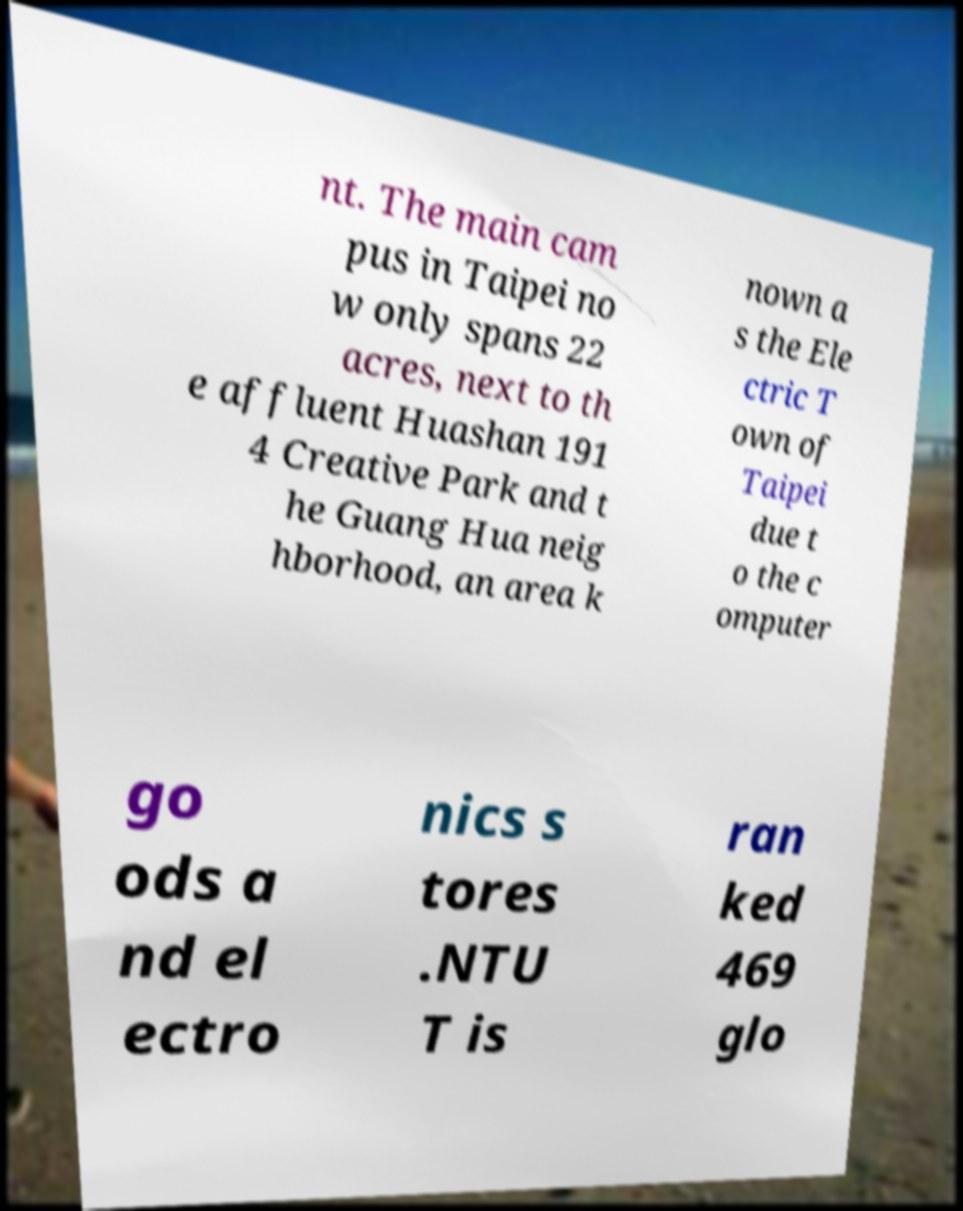Can you accurately transcribe the text from the provided image for me? nt. The main cam pus in Taipei no w only spans 22 acres, next to th e affluent Huashan 191 4 Creative Park and t he Guang Hua neig hborhood, an area k nown a s the Ele ctric T own of Taipei due t o the c omputer go ods a nd el ectro nics s tores .NTU T is ran ked 469 glo 